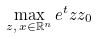Convert formula to latex. <formula><loc_0><loc_0><loc_500><loc_500>\max _ { z , \, x \in \mathbb { R } ^ { n } } e ^ { t } z z _ { 0 }</formula> 